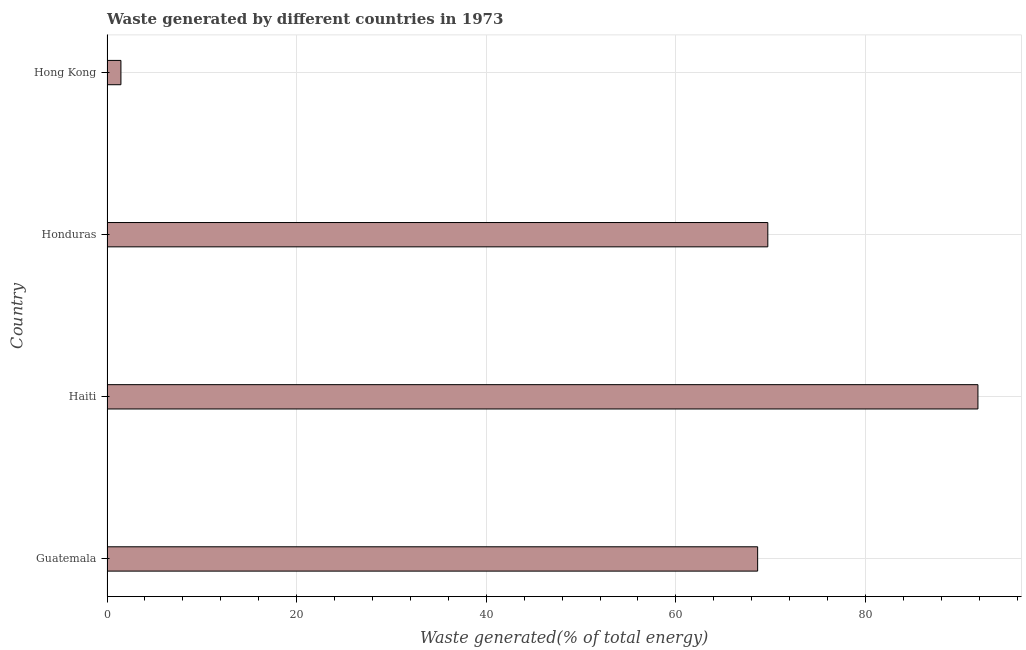What is the title of the graph?
Make the answer very short. Waste generated by different countries in 1973. What is the label or title of the X-axis?
Make the answer very short. Waste generated(% of total energy). What is the label or title of the Y-axis?
Make the answer very short. Country. What is the amount of waste generated in Honduras?
Your response must be concise. 69.69. Across all countries, what is the maximum amount of waste generated?
Provide a short and direct response. 91.85. Across all countries, what is the minimum amount of waste generated?
Ensure brevity in your answer.  1.47. In which country was the amount of waste generated maximum?
Your answer should be compact. Haiti. In which country was the amount of waste generated minimum?
Your response must be concise. Hong Kong. What is the sum of the amount of waste generated?
Provide a succinct answer. 231.63. What is the difference between the amount of waste generated in Haiti and Honduras?
Offer a very short reply. 22.16. What is the average amount of waste generated per country?
Your answer should be very brief. 57.91. What is the median amount of waste generated?
Your answer should be very brief. 69.16. Is the difference between the amount of waste generated in Haiti and Hong Kong greater than the difference between any two countries?
Your answer should be compact. Yes. What is the difference between the highest and the second highest amount of waste generated?
Keep it short and to the point. 22.16. What is the difference between the highest and the lowest amount of waste generated?
Provide a succinct answer. 90.39. In how many countries, is the amount of waste generated greater than the average amount of waste generated taken over all countries?
Your answer should be very brief. 3. How many bars are there?
Ensure brevity in your answer.  4. Are all the bars in the graph horizontal?
Provide a succinct answer. Yes. What is the difference between two consecutive major ticks on the X-axis?
Make the answer very short. 20. What is the Waste generated(% of total energy) in Guatemala?
Give a very brief answer. 68.62. What is the Waste generated(% of total energy) of Haiti?
Ensure brevity in your answer.  91.85. What is the Waste generated(% of total energy) of Honduras?
Ensure brevity in your answer.  69.69. What is the Waste generated(% of total energy) in Hong Kong?
Your response must be concise. 1.47. What is the difference between the Waste generated(% of total energy) in Guatemala and Haiti?
Your response must be concise. -23.23. What is the difference between the Waste generated(% of total energy) in Guatemala and Honduras?
Your answer should be compact. -1.07. What is the difference between the Waste generated(% of total energy) in Guatemala and Hong Kong?
Your response must be concise. 67.15. What is the difference between the Waste generated(% of total energy) in Haiti and Honduras?
Provide a short and direct response. 22.16. What is the difference between the Waste generated(% of total energy) in Haiti and Hong Kong?
Your response must be concise. 90.39. What is the difference between the Waste generated(% of total energy) in Honduras and Hong Kong?
Make the answer very short. 68.22. What is the ratio of the Waste generated(% of total energy) in Guatemala to that in Haiti?
Provide a short and direct response. 0.75. What is the ratio of the Waste generated(% of total energy) in Guatemala to that in Hong Kong?
Offer a very short reply. 46.75. What is the ratio of the Waste generated(% of total energy) in Haiti to that in Honduras?
Offer a terse response. 1.32. What is the ratio of the Waste generated(% of total energy) in Haiti to that in Hong Kong?
Provide a short and direct response. 62.58. What is the ratio of the Waste generated(% of total energy) in Honduras to that in Hong Kong?
Ensure brevity in your answer.  47.48. 